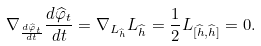<formula> <loc_0><loc_0><loc_500><loc_500>\nabla _ { \frac { d { \widehat { \varphi } } _ { t } } { d t } } \frac { d { \widehat { \varphi } } _ { t } } { d t } = \nabla _ { L _ { \widehat { h } } } L _ { \widehat { h } } = \frac { 1 } { 2 } L _ { [ { \widehat { h } } , { \widehat { h } } ] } = 0 .</formula> 